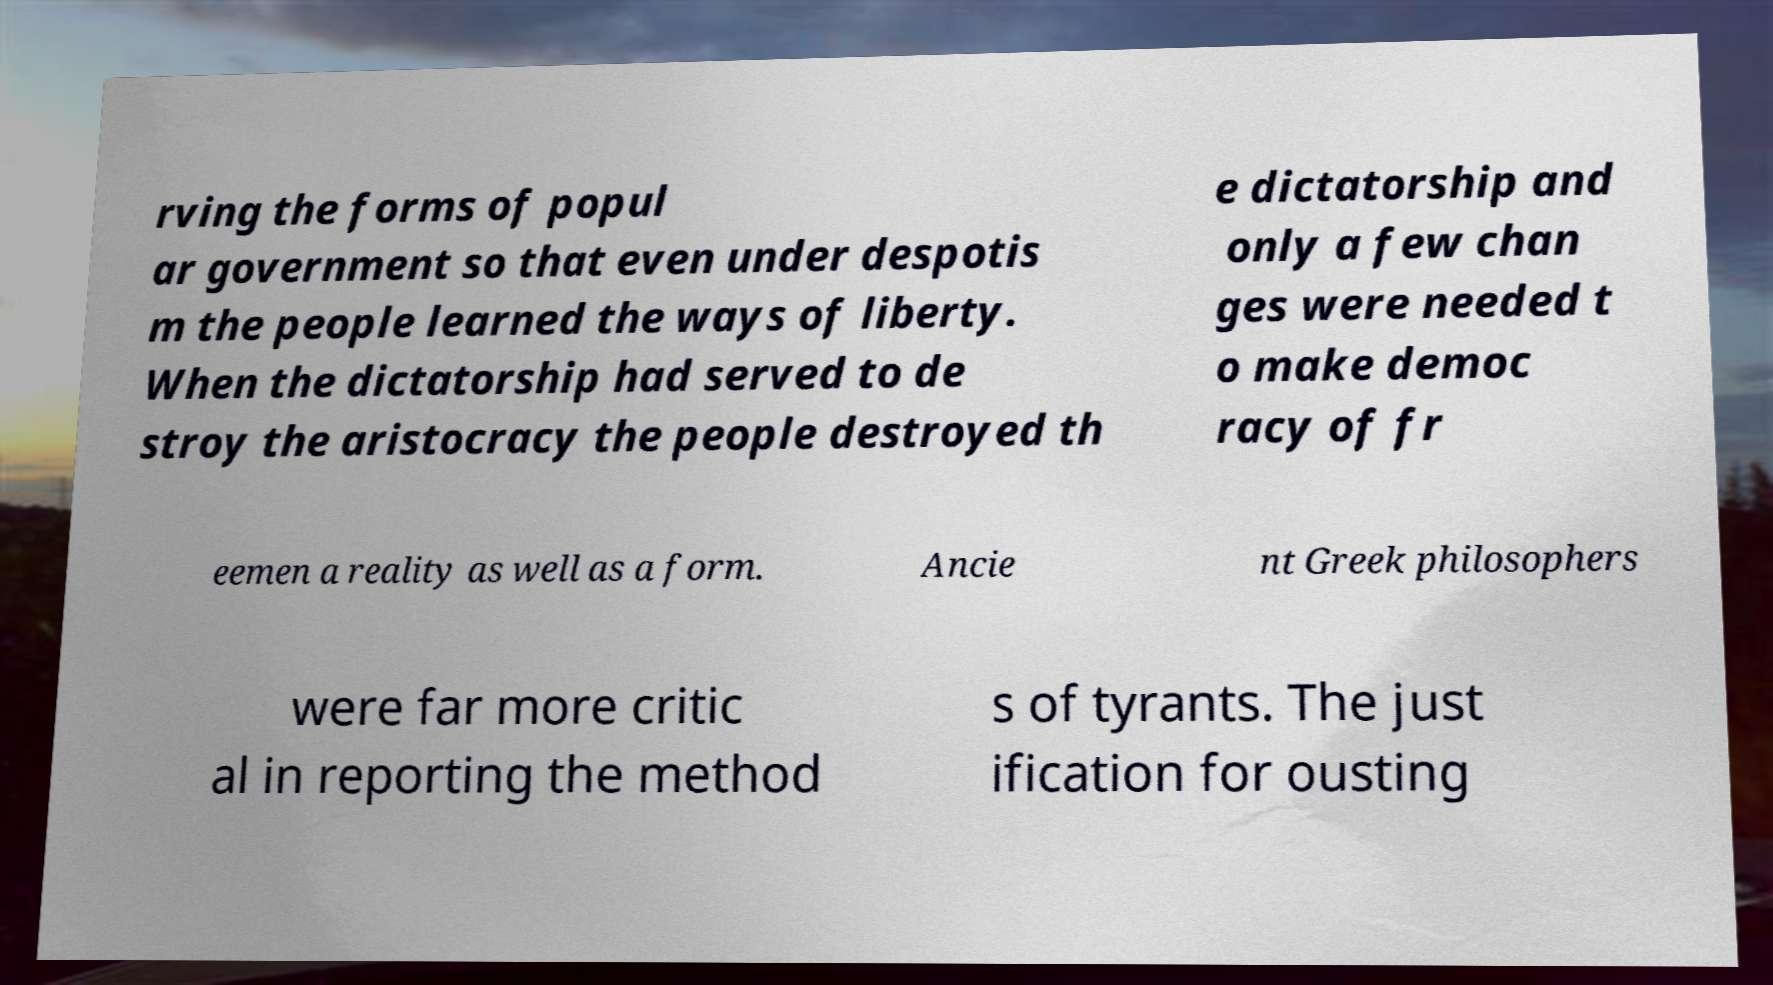Can you accurately transcribe the text from the provided image for me? rving the forms of popul ar government so that even under despotis m the people learned the ways of liberty. When the dictatorship had served to de stroy the aristocracy the people destroyed th e dictatorship and only a few chan ges were needed t o make democ racy of fr eemen a reality as well as a form. Ancie nt Greek philosophers were far more critic al in reporting the method s of tyrants. The just ification for ousting 